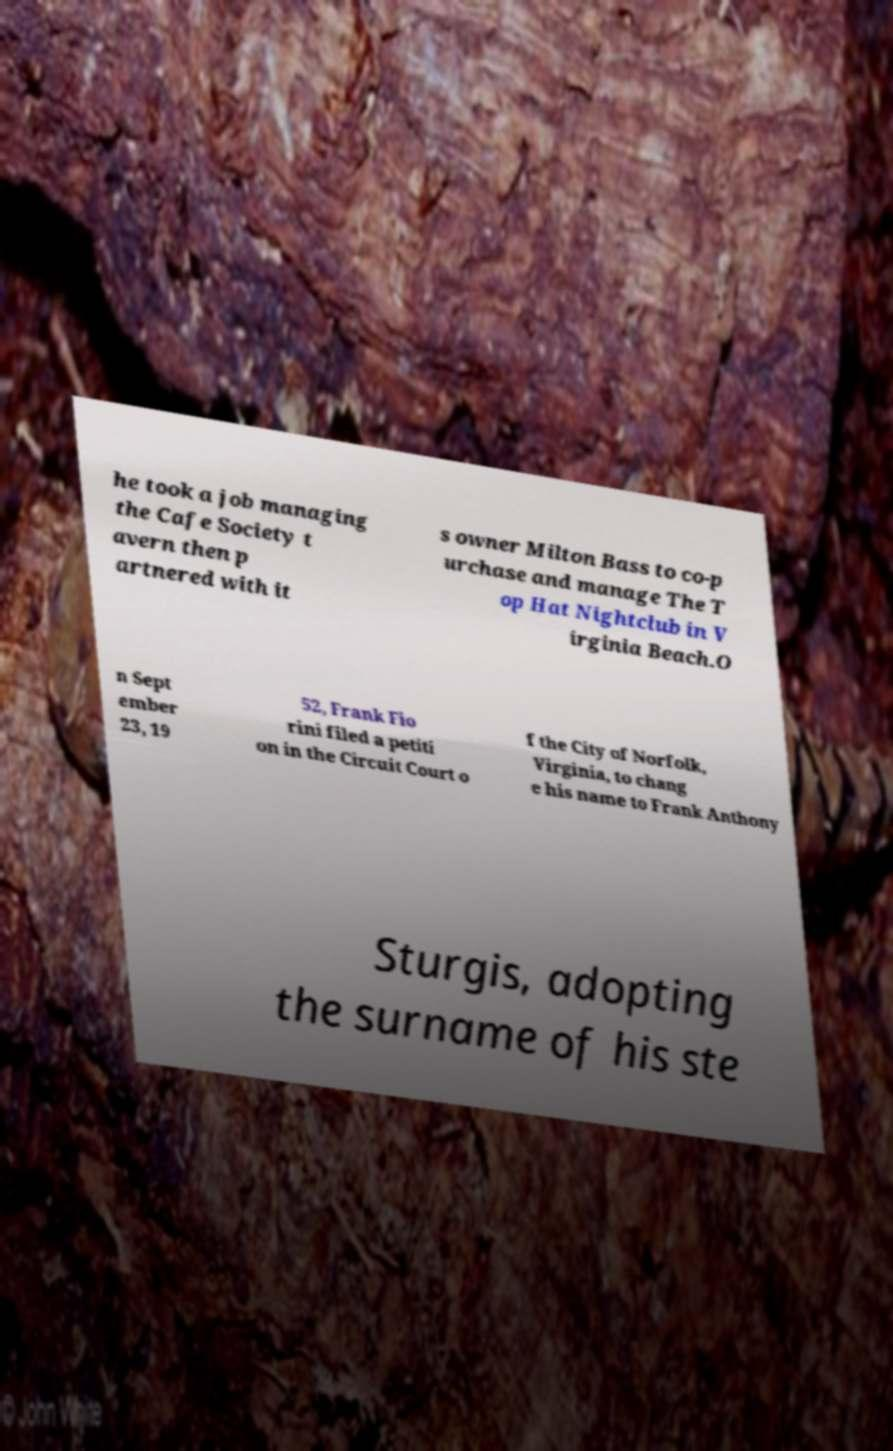I need the written content from this picture converted into text. Can you do that? he took a job managing the Cafe Society t avern then p artnered with it s owner Milton Bass to co-p urchase and manage The T op Hat Nightclub in V irginia Beach.O n Sept ember 23, 19 52, Frank Fio rini filed a petiti on in the Circuit Court o f the City of Norfolk, Virginia, to chang e his name to Frank Anthony Sturgis, adopting the surname of his ste 